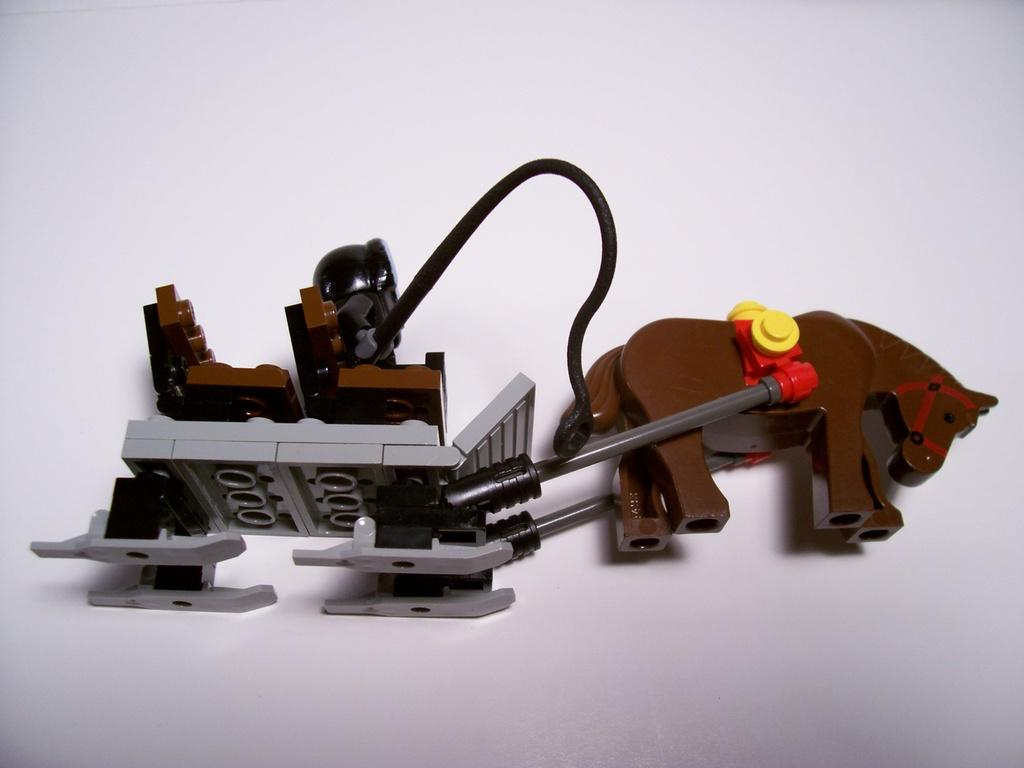What object can be seen in the image? There is a toy in the image. What is the color of the surface on which the toy is placed? The toy is on a white surface. What type of doll is writing an offer on the white surface in the image? There is no doll present in the image, nor is there any writing or offer visible. 